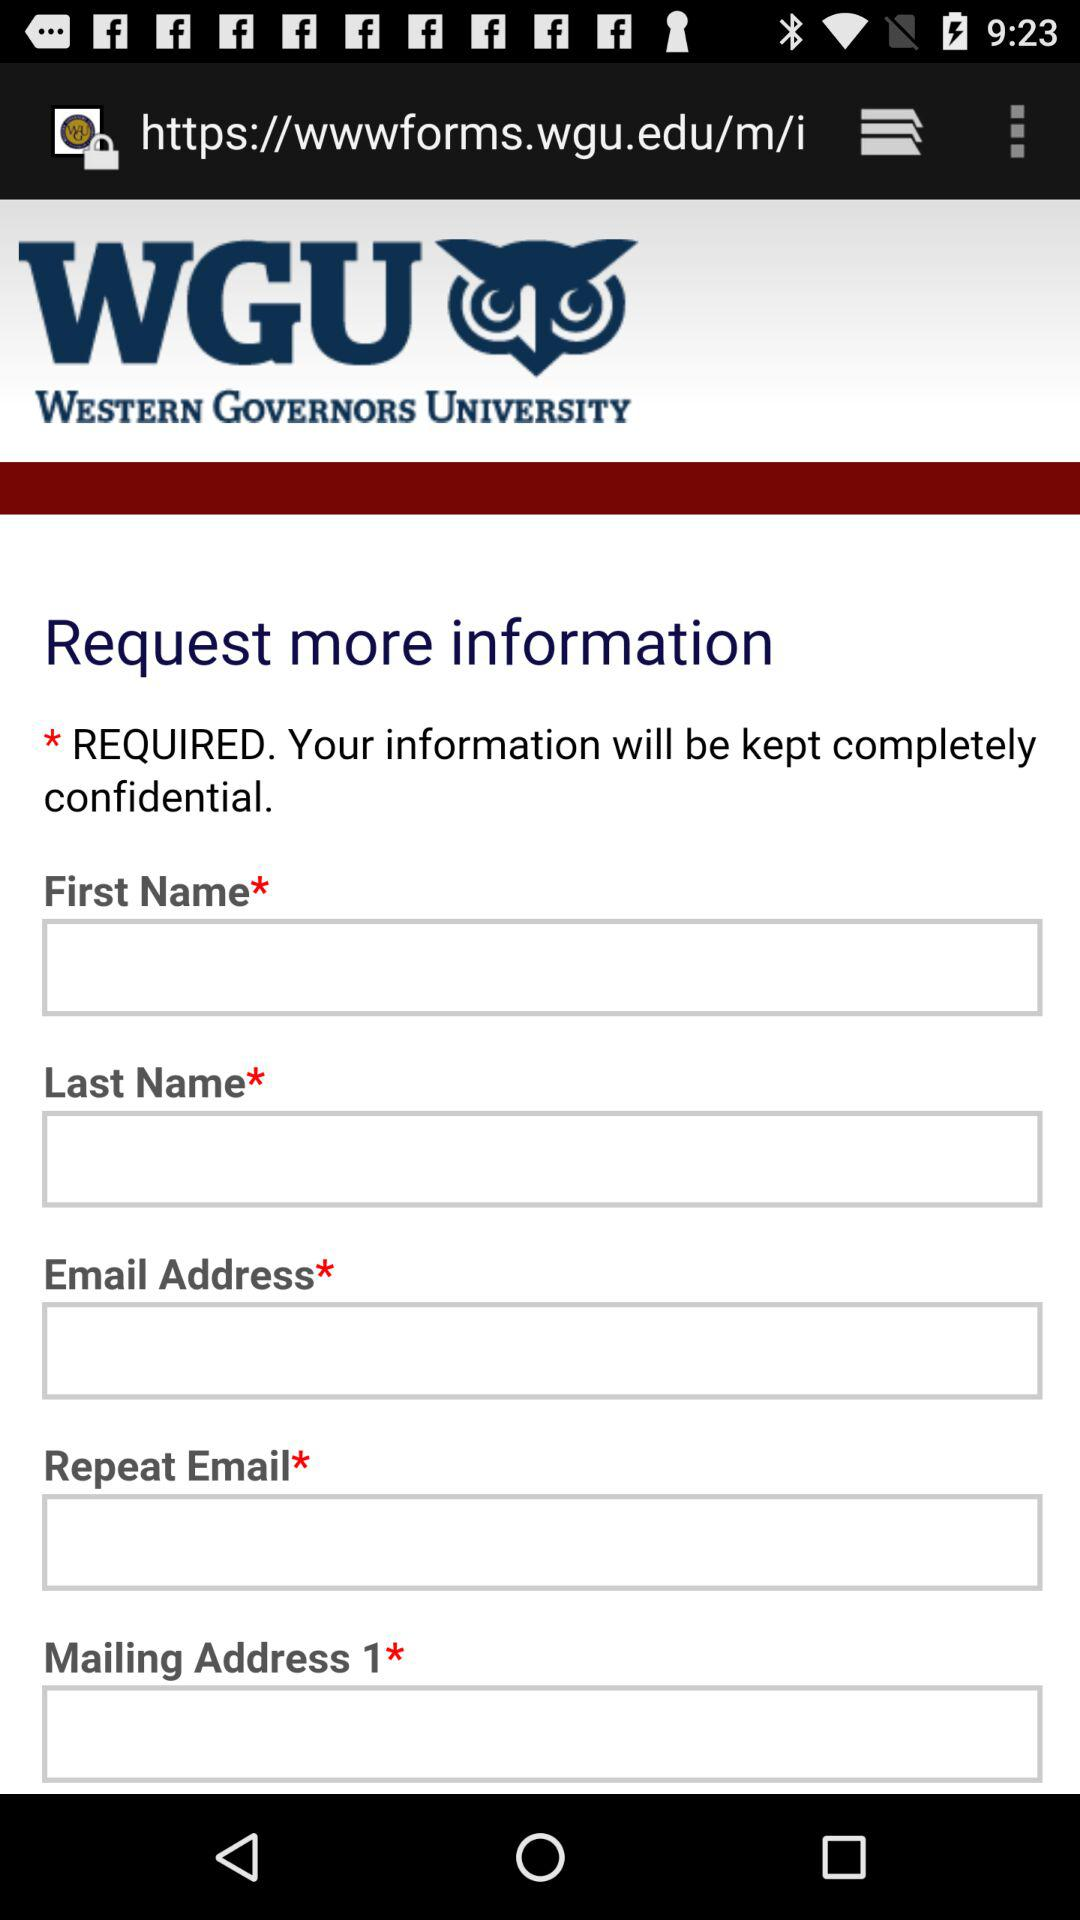What is the name of the university shown? The university name is "WESTERN GOVERNORS UNIVERSITY". 